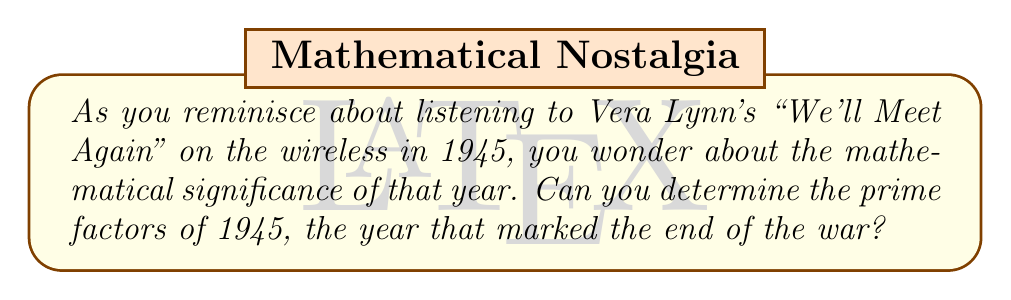Provide a solution to this math problem. Let's approach this step-by-step:

1) First, let's check if 1945 is divisible by small prime numbers:

   $1945 \div 2 = 972.5$ (not divisible by 2)
   $1945 \div 3 = 648.\overline{3}$ (not divisible by 3)
   $1945 \div 5 = 389$ (divisible by 5)

2) We can divide 1945 by 5:

   $1945 = 5 \times 389$

3) Now, we need to check if 389 is prime or can be further factored:

   $\sqrt{389} \approx 19.72$

   We only need to check prime factors up to 19.

4) Checking divisibility:

   $389 \div 2 = 194.5$ (not divisible by 2)
   $389 \div 3 = 129.\overline{6}$ (not divisible by 3)
   $389 \div 5 = 77.8$ (not divisible by 5)
   $389 \div 7 = 55.57...$ (not divisible by 7)
   $389 \div 11 = 35.\overline{36}$ (not divisible by 11)
   $389 \div 13 = 29.92...$ (not divisible by 13)
   $389 \div 17 = 22.88...$ (not divisible by 17)
   $389 \div 19 = 20.47...$ (not divisible by 19)

5) Since 389 is not divisible by any prime up to its square root, it is prime.

Therefore, the prime factorization of 1945 is:

$$1945 = 5 \times 389$$
Answer: $5 \times 389$ 